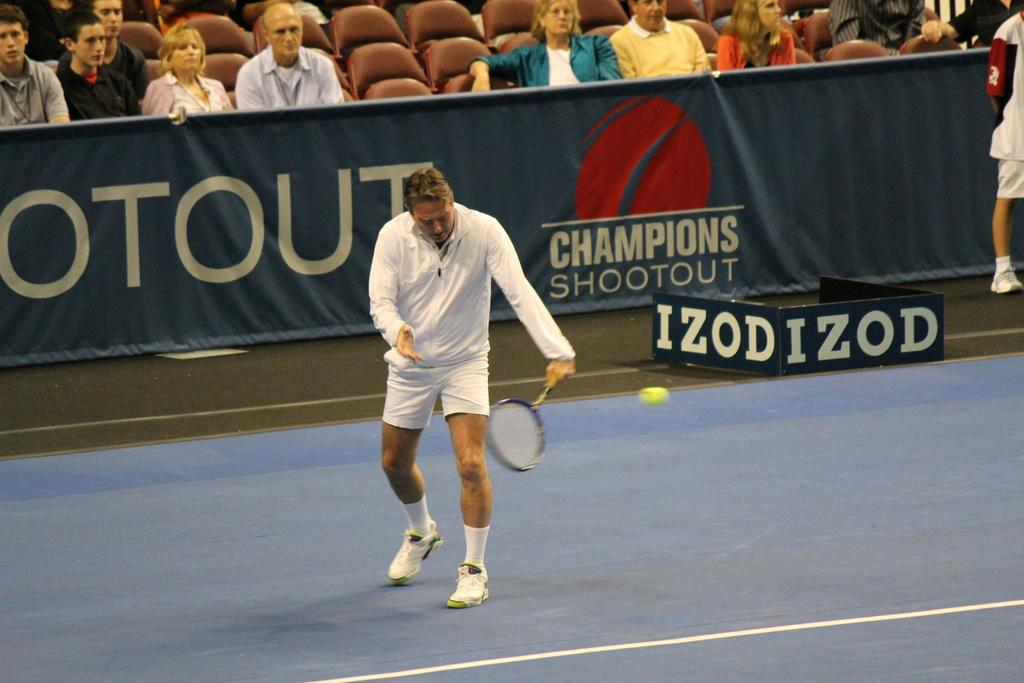What can be seen hanging or displayed in the image? There is a banner in the image. What are the people in the image doing? The people in the image are sitting on chairs. What is the man in the image holding? The man is holding a bat. What type of vegetable is being used as a string to hold the banner in the image? There is no vegetable or string present in the image; the banner is not being held up by any vegetable or string. 